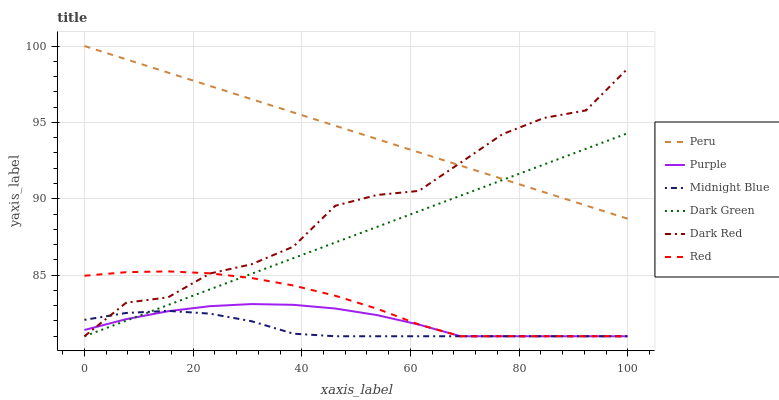Does Midnight Blue have the minimum area under the curve?
Answer yes or no. Yes. Does Peru have the maximum area under the curve?
Answer yes or no. Yes. Does Purple have the minimum area under the curve?
Answer yes or no. No. Does Purple have the maximum area under the curve?
Answer yes or no. No. Is Dark Green the smoothest?
Answer yes or no. Yes. Is Dark Red the roughest?
Answer yes or no. Yes. Is Purple the smoothest?
Answer yes or no. No. Is Purple the roughest?
Answer yes or no. No. Does Peru have the lowest value?
Answer yes or no. No. Does Peru have the highest value?
Answer yes or no. Yes. Does Purple have the highest value?
Answer yes or no. No. Is Purple less than Peru?
Answer yes or no. Yes. Is Peru greater than Red?
Answer yes or no. Yes. Does Red intersect Purple?
Answer yes or no. Yes. Is Red less than Purple?
Answer yes or no. No. Is Red greater than Purple?
Answer yes or no. No. Does Purple intersect Peru?
Answer yes or no. No. 